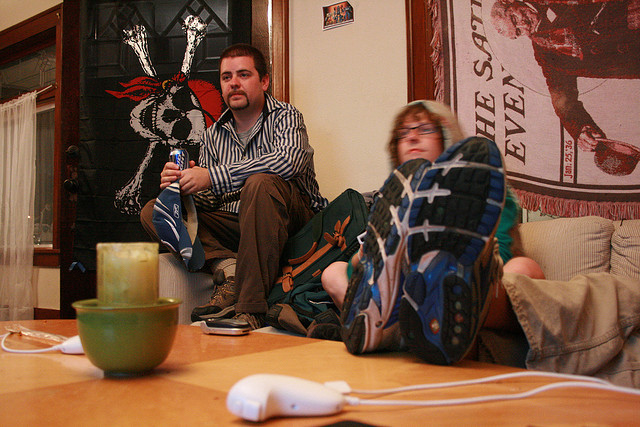Please identify all text content in this image. SAT EVEN HE 